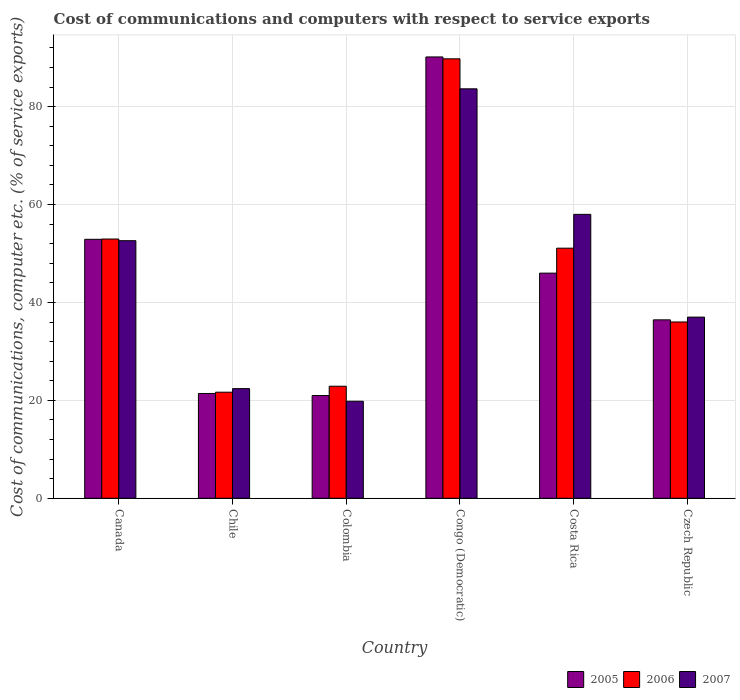How many groups of bars are there?
Provide a short and direct response. 6. Are the number of bars per tick equal to the number of legend labels?
Provide a short and direct response. Yes. In how many cases, is the number of bars for a given country not equal to the number of legend labels?
Your answer should be compact. 0. What is the cost of communications and computers in 2006 in Colombia?
Your answer should be compact. 22.89. Across all countries, what is the maximum cost of communications and computers in 2006?
Ensure brevity in your answer.  89.77. Across all countries, what is the minimum cost of communications and computers in 2005?
Provide a short and direct response. 20.99. In which country was the cost of communications and computers in 2006 maximum?
Offer a very short reply. Congo (Democratic). In which country was the cost of communications and computers in 2005 minimum?
Your response must be concise. Colombia. What is the total cost of communications and computers in 2007 in the graph?
Offer a very short reply. 273.48. What is the difference between the cost of communications and computers in 2006 in Colombia and that in Congo (Democratic)?
Offer a terse response. -66.88. What is the difference between the cost of communications and computers in 2006 in Czech Republic and the cost of communications and computers in 2007 in Congo (Democratic)?
Provide a short and direct response. -47.63. What is the average cost of communications and computers in 2007 per country?
Ensure brevity in your answer.  45.58. What is the difference between the cost of communications and computers of/in 2006 and cost of communications and computers of/in 2005 in Chile?
Your answer should be very brief. 0.26. What is the ratio of the cost of communications and computers in 2005 in Congo (Democratic) to that in Costa Rica?
Keep it short and to the point. 1.96. Is the cost of communications and computers in 2007 in Canada less than that in Costa Rica?
Provide a succinct answer. Yes. What is the difference between the highest and the second highest cost of communications and computers in 2006?
Give a very brief answer. 38.68. What is the difference between the highest and the lowest cost of communications and computers in 2005?
Offer a terse response. 69.16. In how many countries, is the cost of communications and computers in 2006 greater than the average cost of communications and computers in 2006 taken over all countries?
Offer a very short reply. 3. Is the sum of the cost of communications and computers in 2007 in Chile and Colombia greater than the maximum cost of communications and computers in 2006 across all countries?
Keep it short and to the point. No. What does the 2nd bar from the left in Congo (Democratic) represents?
Your response must be concise. 2006. How many countries are there in the graph?
Keep it short and to the point. 6. Are the values on the major ticks of Y-axis written in scientific E-notation?
Offer a very short reply. No. Does the graph contain grids?
Provide a succinct answer. Yes. How are the legend labels stacked?
Make the answer very short. Horizontal. What is the title of the graph?
Offer a very short reply. Cost of communications and computers with respect to service exports. Does "1980" appear as one of the legend labels in the graph?
Provide a succinct answer. No. What is the label or title of the Y-axis?
Give a very brief answer. Cost of communications, computer etc. (% of service exports). What is the Cost of communications, computer etc. (% of service exports) in 2005 in Canada?
Keep it short and to the point. 52.9. What is the Cost of communications, computer etc. (% of service exports) in 2006 in Canada?
Make the answer very short. 52.96. What is the Cost of communications, computer etc. (% of service exports) of 2007 in Canada?
Your answer should be compact. 52.62. What is the Cost of communications, computer etc. (% of service exports) of 2005 in Chile?
Keep it short and to the point. 21.41. What is the Cost of communications, computer etc. (% of service exports) of 2006 in Chile?
Your answer should be compact. 21.67. What is the Cost of communications, computer etc. (% of service exports) of 2007 in Chile?
Your answer should be very brief. 22.4. What is the Cost of communications, computer etc. (% of service exports) in 2005 in Colombia?
Your answer should be compact. 20.99. What is the Cost of communications, computer etc. (% of service exports) in 2006 in Colombia?
Keep it short and to the point. 22.89. What is the Cost of communications, computer etc. (% of service exports) in 2007 in Colombia?
Provide a short and direct response. 19.82. What is the Cost of communications, computer etc. (% of service exports) in 2005 in Congo (Democratic)?
Give a very brief answer. 90.15. What is the Cost of communications, computer etc. (% of service exports) in 2006 in Congo (Democratic)?
Your response must be concise. 89.77. What is the Cost of communications, computer etc. (% of service exports) of 2007 in Congo (Democratic)?
Make the answer very short. 83.64. What is the Cost of communications, computer etc. (% of service exports) of 2005 in Costa Rica?
Make the answer very short. 45.99. What is the Cost of communications, computer etc. (% of service exports) in 2006 in Costa Rica?
Give a very brief answer. 51.09. What is the Cost of communications, computer etc. (% of service exports) of 2007 in Costa Rica?
Provide a short and direct response. 58. What is the Cost of communications, computer etc. (% of service exports) of 2005 in Czech Republic?
Give a very brief answer. 36.45. What is the Cost of communications, computer etc. (% of service exports) of 2006 in Czech Republic?
Your answer should be very brief. 36.01. What is the Cost of communications, computer etc. (% of service exports) of 2007 in Czech Republic?
Provide a short and direct response. 37.01. Across all countries, what is the maximum Cost of communications, computer etc. (% of service exports) of 2005?
Offer a terse response. 90.15. Across all countries, what is the maximum Cost of communications, computer etc. (% of service exports) in 2006?
Offer a very short reply. 89.77. Across all countries, what is the maximum Cost of communications, computer etc. (% of service exports) of 2007?
Offer a terse response. 83.64. Across all countries, what is the minimum Cost of communications, computer etc. (% of service exports) in 2005?
Provide a succinct answer. 20.99. Across all countries, what is the minimum Cost of communications, computer etc. (% of service exports) in 2006?
Make the answer very short. 21.67. Across all countries, what is the minimum Cost of communications, computer etc. (% of service exports) of 2007?
Give a very brief answer. 19.82. What is the total Cost of communications, computer etc. (% of service exports) of 2005 in the graph?
Keep it short and to the point. 267.89. What is the total Cost of communications, computer etc. (% of service exports) of 2006 in the graph?
Provide a short and direct response. 274.39. What is the total Cost of communications, computer etc. (% of service exports) of 2007 in the graph?
Provide a succinct answer. 273.48. What is the difference between the Cost of communications, computer etc. (% of service exports) in 2005 in Canada and that in Chile?
Your answer should be very brief. 31.49. What is the difference between the Cost of communications, computer etc. (% of service exports) in 2006 in Canada and that in Chile?
Your response must be concise. 31.29. What is the difference between the Cost of communications, computer etc. (% of service exports) of 2007 in Canada and that in Chile?
Provide a succinct answer. 30.22. What is the difference between the Cost of communications, computer etc. (% of service exports) of 2005 in Canada and that in Colombia?
Give a very brief answer. 31.91. What is the difference between the Cost of communications, computer etc. (% of service exports) in 2006 in Canada and that in Colombia?
Provide a succinct answer. 30.07. What is the difference between the Cost of communications, computer etc. (% of service exports) of 2007 in Canada and that in Colombia?
Offer a terse response. 32.79. What is the difference between the Cost of communications, computer etc. (% of service exports) of 2005 in Canada and that in Congo (Democratic)?
Keep it short and to the point. -37.25. What is the difference between the Cost of communications, computer etc. (% of service exports) in 2006 in Canada and that in Congo (Democratic)?
Ensure brevity in your answer.  -36.81. What is the difference between the Cost of communications, computer etc. (% of service exports) in 2007 in Canada and that in Congo (Democratic)?
Offer a very short reply. -31.02. What is the difference between the Cost of communications, computer etc. (% of service exports) of 2005 in Canada and that in Costa Rica?
Your answer should be very brief. 6.91. What is the difference between the Cost of communications, computer etc. (% of service exports) in 2006 in Canada and that in Costa Rica?
Your answer should be compact. 1.87. What is the difference between the Cost of communications, computer etc. (% of service exports) in 2007 in Canada and that in Costa Rica?
Ensure brevity in your answer.  -5.38. What is the difference between the Cost of communications, computer etc. (% of service exports) in 2005 in Canada and that in Czech Republic?
Your answer should be compact. 16.45. What is the difference between the Cost of communications, computer etc. (% of service exports) of 2006 in Canada and that in Czech Republic?
Provide a succinct answer. 16.95. What is the difference between the Cost of communications, computer etc. (% of service exports) in 2007 in Canada and that in Czech Republic?
Ensure brevity in your answer.  15.61. What is the difference between the Cost of communications, computer etc. (% of service exports) of 2005 in Chile and that in Colombia?
Provide a short and direct response. 0.42. What is the difference between the Cost of communications, computer etc. (% of service exports) in 2006 in Chile and that in Colombia?
Ensure brevity in your answer.  -1.22. What is the difference between the Cost of communications, computer etc. (% of service exports) in 2007 in Chile and that in Colombia?
Provide a succinct answer. 2.58. What is the difference between the Cost of communications, computer etc. (% of service exports) in 2005 in Chile and that in Congo (Democratic)?
Provide a succinct answer. -68.74. What is the difference between the Cost of communications, computer etc. (% of service exports) in 2006 in Chile and that in Congo (Democratic)?
Offer a terse response. -68.1. What is the difference between the Cost of communications, computer etc. (% of service exports) in 2007 in Chile and that in Congo (Democratic)?
Provide a succinct answer. -61.24. What is the difference between the Cost of communications, computer etc. (% of service exports) of 2005 in Chile and that in Costa Rica?
Provide a succinct answer. -24.58. What is the difference between the Cost of communications, computer etc. (% of service exports) of 2006 in Chile and that in Costa Rica?
Ensure brevity in your answer.  -29.42. What is the difference between the Cost of communications, computer etc. (% of service exports) in 2007 in Chile and that in Costa Rica?
Your answer should be very brief. -35.6. What is the difference between the Cost of communications, computer etc. (% of service exports) of 2005 in Chile and that in Czech Republic?
Make the answer very short. -15.04. What is the difference between the Cost of communications, computer etc. (% of service exports) in 2006 in Chile and that in Czech Republic?
Your answer should be compact. -14.34. What is the difference between the Cost of communications, computer etc. (% of service exports) in 2007 in Chile and that in Czech Republic?
Provide a short and direct response. -14.61. What is the difference between the Cost of communications, computer etc. (% of service exports) of 2005 in Colombia and that in Congo (Democratic)?
Provide a short and direct response. -69.16. What is the difference between the Cost of communications, computer etc. (% of service exports) of 2006 in Colombia and that in Congo (Democratic)?
Your answer should be very brief. -66.88. What is the difference between the Cost of communications, computer etc. (% of service exports) of 2007 in Colombia and that in Congo (Democratic)?
Keep it short and to the point. -63.82. What is the difference between the Cost of communications, computer etc. (% of service exports) in 2005 in Colombia and that in Costa Rica?
Keep it short and to the point. -25. What is the difference between the Cost of communications, computer etc. (% of service exports) in 2006 in Colombia and that in Costa Rica?
Ensure brevity in your answer.  -28.2. What is the difference between the Cost of communications, computer etc. (% of service exports) in 2007 in Colombia and that in Costa Rica?
Keep it short and to the point. -38.18. What is the difference between the Cost of communications, computer etc. (% of service exports) of 2005 in Colombia and that in Czech Republic?
Provide a succinct answer. -15.46. What is the difference between the Cost of communications, computer etc. (% of service exports) in 2006 in Colombia and that in Czech Republic?
Ensure brevity in your answer.  -13.12. What is the difference between the Cost of communications, computer etc. (% of service exports) in 2007 in Colombia and that in Czech Republic?
Your answer should be compact. -17.18. What is the difference between the Cost of communications, computer etc. (% of service exports) of 2005 in Congo (Democratic) and that in Costa Rica?
Provide a short and direct response. 44.16. What is the difference between the Cost of communications, computer etc. (% of service exports) in 2006 in Congo (Democratic) and that in Costa Rica?
Provide a succinct answer. 38.68. What is the difference between the Cost of communications, computer etc. (% of service exports) of 2007 in Congo (Democratic) and that in Costa Rica?
Offer a very short reply. 25.64. What is the difference between the Cost of communications, computer etc. (% of service exports) of 2005 in Congo (Democratic) and that in Czech Republic?
Provide a short and direct response. 53.7. What is the difference between the Cost of communications, computer etc. (% of service exports) in 2006 in Congo (Democratic) and that in Czech Republic?
Provide a short and direct response. 53.75. What is the difference between the Cost of communications, computer etc. (% of service exports) in 2007 in Congo (Democratic) and that in Czech Republic?
Ensure brevity in your answer.  46.63. What is the difference between the Cost of communications, computer etc. (% of service exports) of 2005 in Costa Rica and that in Czech Republic?
Your answer should be very brief. 9.54. What is the difference between the Cost of communications, computer etc. (% of service exports) of 2006 in Costa Rica and that in Czech Republic?
Make the answer very short. 15.08. What is the difference between the Cost of communications, computer etc. (% of service exports) of 2007 in Costa Rica and that in Czech Republic?
Provide a succinct answer. 20.99. What is the difference between the Cost of communications, computer etc. (% of service exports) of 2005 in Canada and the Cost of communications, computer etc. (% of service exports) of 2006 in Chile?
Keep it short and to the point. 31.23. What is the difference between the Cost of communications, computer etc. (% of service exports) of 2005 in Canada and the Cost of communications, computer etc. (% of service exports) of 2007 in Chile?
Provide a succinct answer. 30.5. What is the difference between the Cost of communications, computer etc. (% of service exports) in 2006 in Canada and the Cost of communications, computer etc. (% of service exports) in 2007 in Chile?
Provide a succinct answer. 30.56. What is the difference between the Cost of communications, computer etc. (% of service exports) in 2005 in Canada and the Cost of communications, computer etc. (% of service exports) in 2006 in Colombia?
Your answer should be very brief. 30.01. What is the difference between the Cost of communications, computer etc. (% of service exports) in 2005 in Canada and the Cost of communications, computer etc. (% of service exports) in 2007 in Colombia?
Keep it short and to the point. 33.08. What is the difference between the Cost of communications, computer etc. (% of service exports) in 2006 in Canada and the Cost of communications, computer etc. (% of service exports) in 2007 in Colombia?
Ensure brevity in your answer.  33.14. What is the difference between the Cost of communications, computer etc. (% of service exports) of 2005 in Canada and the Cost of communications, computer etc. (% of service exports) of 2006 in Congo (Democratic)?
Make the answer very short. -36.87. What is the difference between the Cost of communications, computer etc. (% of service exports) in 2005 in Canada and the Cost of communications, computer etc. (% of service exports) in 2007 in Congo (Democratic)?
Keep it short and to the point. -30.74. What is the difference between the Cost of communications, computer etc. (% of service exports) of 2006 in Canada and the Cost of communications, computer etc. (% of service exports) of 2007 in Congo (Democratic)?
Give a very brief answer. -30.68. What is the difference between the Cost of communications, computer etc. (% of service exports) of 2005 in Canada and the Cost of communications, computer etc. (% of service exports) of 2006 in Costa Rica?
Give a very brief answer. 1.81. What is the difference between the Cost of communications, computer etc. (% of service exports) of 2005 in Canada and the Cost of communications, computer etc. (% of service exports) of 2007 in Costa Rica?
Give a very brief answer. -5.1. What is the difference between the Cost of communications, computer etc. (% of service exports) in 2006 in Canada and the Cost of communications, computer etc. (% of service exports) in 2007 in Costa Rica?
Ensure brevity in your answer.  -5.04. What is the difference between the Cost of communications, computer etc. (% of service exports) in 2005 in Canada and the Cost of communications, computer etc. (% of service exports) in 2006 in Czech Republic?
Provide a succinct answer. 16.89. What is the difference between the Cost of communications, computer etc. (% of service exports) in 2005 in Canada and the Cost of communications, computer etc. (% of service exports) in 2007 in Czech Republic?
Provide a short and direct response. 15.89. What is the difference between the Cost of communications, computer etc. (% of service exports) in 2006 in Canada and the Cost of communications, computer etc. (% of service exports) in 2007 in Czech Republic?
Ensure brevity in your answer.  15.95. What is the difference between the Cost of communications, computer etc. (% of service exports) in 2005 in Chile and the Cost of communications, computer etc. (% of service exports) in 2006 in Colombia?
Make the answer very short. -1.48. What is the difference between the Cost of communications, computer etc. (% of service exports) in 2005 in Chile and the Cost of communications, computer etc. (% of service exports) in 2007 in Colombia?
Your answer should be compact. 1.59. What is the difference between the Cost of communications, computer etc. (% of service exports) in 2006 in Chile and the Cost of communications, computer etc. (% of service exports) in 2007 in Colombia?
Your answer should be very brief. 1.85. What is the difference between the Cost of communications, computer etc. (% of service exports) of 2005 in Chile and the Cost of communications, computer etc. (% of service exports) of 2006 in Congo (Democratic)?
Provide a short and direct response. -68.36. What is the difference between the Cost of communications, computer etc. (% of service exports) of 2005 in Chile and the Cost of communications, computer etc. (% of service exports) of 2007 in Congo (Democratic)?
Give a very brief answer. -62.23. What is the difference between the Cost of communications, computer etc. (% of service exports) of 2006 in Chile and the Cost of communications, computer etc. (% of service exports) of 2007 in Congo (Democratic)?
Offer a terse response. -61.97. What is the difference between the Cost of communications, computer etc. (% of service exports) of 2005 in Chile and the Cost of communications, computer etc. (% of service exports) of 2006 in Costa Rica?
Your answer should be compact. -29.68. What is the difference between the Cost of communications, computer etc. (% of service exports) of 2005 in Chile and the Cost of communications, computer etc. (% of service exports) of 2007 in Costa Rica?
Your answer should be very brief. -36.59. What is the difference between the Cost of communications, computer etc. (% of service exports) in 2006 in Chile and the Cost of communications, computer etc. (% of service exports) in 2007 in Costa Rica?
Ensure brevity in your answer.  -36.33. What is the difference between the Cost of communications, computer etc. (% of service exports) in 2005 in Chile and the Cost of communications, computer etc. (% of service exports) in 2006 in Czech Republic?
Make the answer very short. -14.6. What is the difference between the Cost of communications, computer etc. (% of service exports) of 2005 in Chile and the Cost of communications, computer etc. (% of service exports) of 2007 in Czech Republic?
Provide a short and direct response. -15.6. What is the difference between the Cost of communications, computer etc. (% of service exports) in 2006 in Chile and the Cost of communications, computer etc. (% of service exports) in 2007 in Czech Republic?
Make the answer very short. -15.34. What is the difference between the Cost of communications, computer etc. (% of service exports) of 2005 in Colombia and the Cost of communications, computer etc. (% of service exports) of 2006 in Congo (Democratic)?
Provide a short and direct response. -68.78. What is the difference between the Cost of communications, computer etc. (% of service exports) in 2005 in Colombia and the Cost of communications, computer etc. (% of service exports) in 2007 in Congo (Democratic)?
Your answer should be compact. -62.65. What is the difference between the Cost of communications, computer etc. (% of service exports) of 2006 in Colombia and the Cost of communications, computer etc. (% of service exports) of 2007 in Congo (Democratic)?
Provide a short and direct response. -60.75. What is the difference between the Cost of communications, computer etc. (% of service exports) in 2005 in Colombia and the Cost of communications, computer etc. (% of service exports) in 2006 in Costa Rica?
Your response must be concise. -30.1. What is the difference between the Cost of communications, computer etc. (% of service exports) in 2005 in Colombia and the Cost of communications, computer etc. (% of service exports) in 2007 in Costa Rica?
Your answer should be very brief. -37.01. What is the difference between the Cost of communications, computer etc. (% of service exports) of 2006 in Colombia and the Cost of communications, computer etc. (% of service exports) of 2007 in Costa Rica?
Offer a very short reply. -35.11. What is the difference between the Cost of communications, computer etc. (% of service exports) of 2005 in Colombia and the Cost of communications, computer etc. (% of service exports) of 2006 in Czech Republic?
Keep it short and to the point. -15.02. What is the difference between the Cost of communications, computer etc. (% of service exports) of 2005 in Colombia and the Cost of communications, computer etc. (% of service exports) of 2007 in Czech Republic?
Your answer should be compact. -16.02. What is the difference between the Cost of communications, computer etc. (% of service exports) in 2006 in Colombia and the Cost of communications, computer etc. (% of service exports) in 2007 in Czech Republic?
Ensure brevity in your answer.  -14.12. What is the difference between the Cost of communications, computer etc. (% of service exports) of 2005 in Congo (Democratic) and the Cost of communications, computer etc. (% of service exports) of 2006 in Costa Rica?
Keep it short and to the point. 39.06. What is the difference between the Cost of communications, computer etc. (% of service exports) of 2005 in Congo (Democratic) and the Cost of communications, computer etc. (% of service exports) of 2007 in Costa Rica?
Make the answer very short. 32.15. What is the difference between the Cost of communications, computer etc. (% of service exports) in 2006 in Congo (Democratic) and the Cost of communications, computer etc. (% of service exports) in 2007 in Costa Rica?
Ensure brevity in your answer.  31.77. What is the difference between the Cost of communications, computer etc. (% of service exports) in 2005 in Congo (Democratic) and the Cost of communications, computer etc. (% of service exports) in 2006 in Czech Republic?
Provide a short and direct response. 54.14. What is the difference between the Cost of communications, computer etc. (% of service exports) of 2005 in Congo (Democratic) and the Cost of communications, computer etc. (% of service exports) of 2007 in Czech Republic?
Offer a very short reply. 53.14. What is the difference between the Cost of communications, computer etc. (% of service exports) in 2006 in Congo (Democratic) and the Cost of communications, computer etc. (% of service exports) in 2007 in Czech Republic?
Offer a terse response. 52.76. What is the difference between the Cost of communications, computer etc. (% of service exports) of 2005 in Costa Rica and the Cost of communications, computer etc. (% of service exports) of 2006 in Czech Republic?
Ensure brevity in your answer.  9.98. What is the difference between the Cost of communications, computer etc. (% of service exports) in 2005 in Costa Rica and the Cost of communications, computer etc. (% of service exports) in 2007 in Czech Republic?
Keep it short and to the point. 8.98. What is the difference between the Cost of communications, computer etc. (% of service exports) in 2006 in Costa Rica and the Cost of communications, computer etc. (% of service exports) in 2007 in Czech Republic?
Your response must be concise. 14.08. What is the average Cost of communications, computer etc. (% of service exports) of 2005 per country?
Provide a succinct answer. 44.65. What is the average Cost of communications, computer etc. (% of service exports) of 2006 per country?
Offer a very short reply. 45.73. What is the average Cost of communications, computer etc. (% of service exports) in 2007 per country?
Your response must be concise. 45.58. What is the difference between the Cost of communications, computer etc. (% of service exports) of 2005 and Cost of communications, computer etc. (% of service exports) of 2006 in Canada?
Offer a very short reply. -0.06. What is the difference between the Cost of communications, computer etc. (% of service exports) in 2005 and Cost of communications, computer etc. (% of service exports) in 2007 in Canada?
Provide a short and direct response. 0.28. What is the difference between the Cost of communications, computer etc. (% of service exports) in 2006 and Cost of communications, computer etc. (% of service exports) in 2007 in Canada?
Provide a short and direct response. 0.34. What is the difference between the Cost of communications, computer etc. (% of service exports) of 2005 and Cost of communications, computer etc. (% of service exports) of 2006 in Chile?
Your answer should be compact. -0.26. What is the difference between the Cost of communications, computer etc. (% of service exports) of 2005 and Cost of communications, computer etc. (% of service exports) of 2007 in Chile?
Ensure brevity in your answer.  -0.99. What is the difference between the Cost of communications, computer etc. (% of service exports) in 2006 and Cost of communications, computer etc. (% of service exports) in 2007 in Chile?
Provide a succinct answer. -0.73. What is the difference between the Cost of communications, computer etc. (% of service exports) of 2005 and Cost of communications, computer etc. (% of service exports) of 2006 in Colombia?
Make the answer very short. -1.9. What is the difference between the Cost of communications, computer etc. (% of service exports) in 2005 and Cost of communications, computer etc. (% of service exports) in 2007 in Colombia?
Provide a short and direct response. 1.17. What is the difference between the Cost of communications, computer etc. (% of service exports) of 2006 and Cost of communications, computer etc. (% of service exports) of 2007 in Colombia?
Your answer should be compact. 3.07. What is the difference between the Cost of communications, computer etc. (% of service exports) in 2005 and Cost of communications, computer etc. (% of service exports) in 2006 in Congo (Democratic)?
Provide a short and direct response. 0.38. What is the difference between the Cost of communications, computer etc. (% of service exports) in 2005 and Cost of communications, computer etc. (% of service exports) in 2007 in Congo (Democratic)?
Offer a terse response. 6.51. What is the difference between the Cost of communications, computer etc. (% of service exports) in 2006 and Cost of communications, computer etc. (% of service exports) in 2007 in Congo (Democratic)?
Keep it short and to the point. 6.13. What is the difference between the Cost of communications, computer etc. (% of service exports) of 2005 and Cost of communications, computer etc. (% of service exports) of 2006 in Costa Rica?
Provide a short and direct response. -5.1. What is the difference between the Cost of communications, computer etc. (% of service exports) of 2005 and Cost of communications, computer etc. (% of service exports) of 2007 in Costa Rica?
Offer a very short reply. -12.01. What is the difference between the Cost of communications, computer etc. (% of service exports) of 2006 and Cost of communications, computer etc. (% of service exports) of 2007 in Costa Rica?
Give a very brief answer. -6.91. What is the difference between the Cost of communications, computer etc. (% of service exports) of 2005 and Cost of communications, computer etc. (% of service exports) of 2006 in Czech Republic?
Keep it short and to the point. 0.44. What is the difference between the Cost of communications, computer etc. (% of service exports) in 2005 and Cost of communications, computer etc. (% of service exports) in 2007 in Czech Republic?
Your answer should be very brief. -0.56. What is the difference between the Cost of communications, computer etc. (% of service exports) of 2006 and Cost of communications, computer etc. (% of service exports) of 2007 in Czech Republic?
Provide a succinct answer. -0.99. What is the ratio of the Cost of communications, computer etc. (% of service exports) in 2005 in Canada to that in Chile?
Provide a succinct answer. 2.47. What is the ratio of the Cost of communications, computer etc. (% of service exports) of 2006 in Canada to that in Chile?
Give a very brief answer. 2.44. What is the ratio of the Cost of communications, computer etc. (% of service exports) of 2007 in Canada to that in Chile?
Keep it short and to the point. 2.35. What is the ratio of the Cost of communications, computer etc. (% of service exports) in 2005 in Canada to that in Colombia?
Provide a succinct answer. 2.52. What is the ratio of the Cost of communications, computer etc. (% of service exports) of 2006 in Canada to that in Colombia?
Provide a short and direct response. 2.31. What is the ratio of the Cost of communications, computer etc. (% of service exports) of 2007 in Canada to that in Colombia?
Your response must be concise. 2.65. What is the ratio of the Cost of communications, computer etc. (% of service exports) in 2005 in Canada to that in Congo (Democratic)?
Provide a short and direct response. 0.59. What is the ratio of the Cost of communications, computer etc. (% of service exports) in 2006 in Canada to that in Congo (Democratic)?
Keep it short and to the point. 0.59. What is the ratio of the Cost of communications, computer etc. (% of service exports) of 2007 in Canada to that in Congo (Democratic)?
Offer a terse response. 0.63. What is the ratio of the Cost of communications, computer etc. (% of service exports) in 2005 in Canada to that in Costa Rica?
Your answer should be very brief. 1.15. What is the ratio of the Cost of communications, computer etc. (% of service exports) in 2006 in Canada to that in Costa Rica?
Your answer should be very brief. 1.04. What is the ratio of the Cost of communications, computer etc. (% of service exports) in 2007 in Canada to that in Costa Rica?
Offer a terse response. 0.91. What is the ratio of the Cost of communications, computer etc. (% of service exports) of 2005 in Canada to that in Czech Republic?
Your answer should be very brief. 1.45. What is the ratio of the Cost of communications, computer etc. (% of service exports) of 2006 in Canada to that in Czech Republic?
Ensure brevity in your answer.  1.47. What is the ratio of the Cost of communications, computer etc. (% of service exports) of 2007 in Canada to that in Czech Republic?
Your response must be concise. 1.42. What is the ratio of the Cost of communications, computer etc. (% of service exports) in 2005 in Chile to that in Colombia?
Ensure brevity in your answer.  1.02. What is the ratio of the Cost of communications, computer etc. (% of service exports) in 2006 in Chile to that in Colombia?
Give a very brief answer. 0.95. What is the ratio of the Cost of communications, computer etc. (% of service exports) in 2007 in Chile to that in Colombia?
Make the answer very short. 1.13. What is the ratio of the Cost of communications, computer etc. (% of service exports) of 2005 in Chile to that in Congo (Democratic)?
Ensure brevity in your answer.  0.24. What is the ratio of the Cost of communications, computer etc. (% of service exports) of 2006 in Chile to that in Congo (Democratic)?
Give a very brief answer. 0.24. What is the ratio of the Cost of communications, computer etc. (% of service exports) of 2007 in Chile to that in Congo (Democratic)?
Your answer should be very brief. 0.27. What is the ratio of the Cost of communications, computer etc. (% of service exports) of 2005 in Chile to that in Costa Rica?
Keep it short and to the point. 0.47. What is the ratio of the Cost of communications, computer etc. (% of service exports) of 2006 in Chile to that in Costa Rica?
Keep it short and to the point. 0.42. What is the ratio of the Cost of communications, computer etc. (% of service exports) of 2007 in Chile to that in Costa Rica?
Give a very brief answer. 0.39. What is the ratio of the Cost of communications, computer etc. (% of service exports) in 2005 in Chile to that in Czech Republic?
Make the answer very short. 0.59. What is the ratio of the Cost of communications, computer etc. (% of service exports) in 2006 in Chile to that in Czech Republic?
Offer a very short reply. 0.6. What is the ratio of the Cost of communications, computer etc. (% of service exports) in 2007 in Chile to that in Czech Republic?
Keep it short and to the point. 0.61. What is the ratio of the Cost of communications, computer etc. (% of service exports) of 2005 in Colombia to that in Congo (Democratic)?
Offer a very short reply. 0.23. What is the ratio of the Cost of communications, computer etc. (% of service exports) of 2006 in Colombia to that in Congo (Democratic)?
Your answer should be compact. 0.26. What is the ratio of the Cost of communications, computer etc. (% of service exports) in 2007 in Colombia to that in Congo (Democratic)?
Your answer should be compact. 0.24. What is the ratio of the Cost of communications, computer etc. (% of service exports) of 2005 in Colombia to that in Costa Rica?
Your response must be concise. 0.46. What is the ratio of the Cost of communications, computer etc. (% of service exports) of 2006 in Colombia to that in Costa Rica?
Provide a short and direct response. 0.45. What is the ratio of the Cost of communications, computer etc. (% of service exports) of 2007 in Colombia to that in Costa Rica?
Keep it short and to the point. 0.34. What is the ratio of the Cost of communications, computer etc. (% of service exports) of 2005 in Colombia to that in Czech Republic?
Keep it short and to the point. 0.58. What is the ratio of the Cost of communications, computer etc. (% of service exports) of 2006 in Colombia to that in Czech Republic?
Keep it short and to the point. 0.64. What is the ratio of the Cost of communications, computer etc. (% of service exports) of 2007 in Colombia to that in Czech Republic?
Give a very brief answer. 0.54. What is the ratio of the Cost of communications, computer etc. (% of service exports) of 2005 in Congo (Democratic) to that in Costa Rica?
Your answer should be compact. 1.96. What is the ratio of the Cost of communications, computer etc. (% of service exports) of 2006 in Congo (Democratic) to that in Costa Rica?
Keep it short and to the point. 1.76. What is the ratio of the Cost of communications, computer etc. (% of service exports) of 2007 in Congo (Democratic) to that in Costa Rica?
Provide a short and direct response. 1.44. What is the ratio of the Cost of communications, computer etc. (% of service exports) in 2005 in Congo (Democratic) to that in Czech Republic?
Make the answer very short. 2.47. What is the ratio of the Cost of communications, computer etc. (% of service exports) in 2006 in Congo (Democratic) to that in Czech Republic?
Give a very brief answer. 2.49. What is the ratio of the Cost of communications, computer etc. (% of service exports) of 2007 in Congo (Democratic) to that in Czech Republic?
Provide a succinct answer. 2.26. What is the ratio of the Cost of communications, computer etc. (% of service exports) in 2005 in Costa Rica to that in Czech Republic?
Keep it short and to the point. 1.26. What is the ratio of the Cost of communications, computer etc. (% of service exports) of 2006 in Costa Rica to that in Czech Republic?
Provide a short and direct response. 1.42. What is the ratio of the Cost of communications, computer etc. (% of service exports) in 2007 in Costa Rica to that in Czech Republic?
Ensure brevity in your answer.  1.57. What is the difference between the highest and the second highest Cost of communications, computer etc. (% of service exports) in 2005?
Keep it short and to the point. 37.25. What is the difference between the highest and the second highest Cost of communications, computer etc. (% of service exports) of 2006?
Your answer should be very brief. 36.81. What is the difference between the highest and the second highest Cost of communications, computer etc. (% of service exports) in 2007?
Your response must be concise. 25.64. What is the difference between the highest and the lowest Cost of communications, computer etc. (% of service exports) of 2005?
Offer a very short reply. 69.16. What is the difference between the highest and the lowest Cost of communications, computer etc. (% of service exports) in 2006?
Provide a short and direct response. 68.1. What is the difference between the highest and the lowest Cost of communications, computer etc. (% of service exports) in 2007?
Offer a terse response. 63.82. 